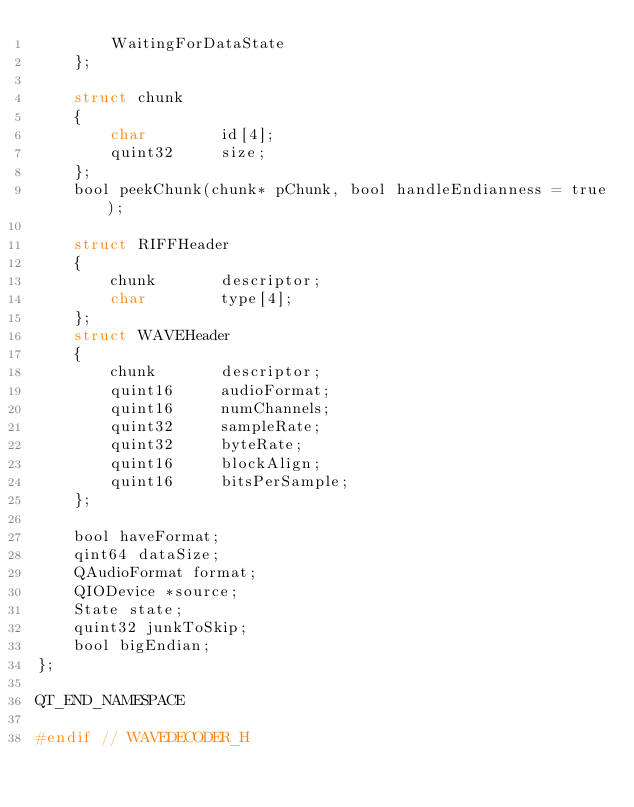Convert code to text. <code><loc_0><loc_0><loc_500><loc_500><_C_>        WaitingForDataState
    };

    struct chunk
    {
        char        id[4];
        quint32     size;
    };
    bool peekChunk(chunk* pChunk, bool handleEndianness = true);

    struct RIFFHeader
    {
        chunk       descriptor;
        char        type[4];
    };
    struct WAVEHeader
    {
        chunk       descriptor;
        quint16     audioFormat;
        quint16     numChannels;
        quint32     sampleRate;
        quint32     byteRate;
        quint16     blockAlign;
        quint16     bitsPerSample;
    };

    bool haveFormat;
    qint64 dataSize;
    QAudioFormat format;
    QIODevice *source;
    State state;
    quint32 junkToSkip;
    bool bigEndian;
};

QT_END_NAMESPACE

#endif // WAVEDECODER_H
</code> 